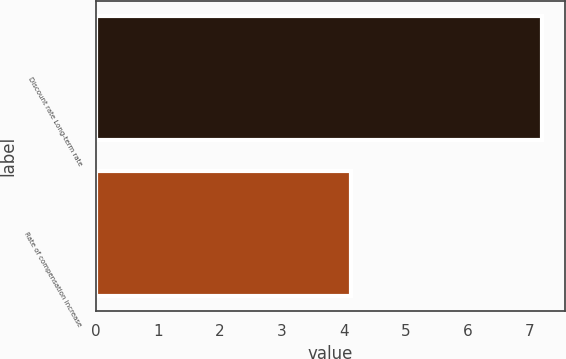<chart> <loc_0><loc_0><loc_500><loc_500><bar_chart><fcel>Discount rate Long-term rate<fcel>Rate of compensation increase<nl><fcel>7.2<fcel>4.11<nl></chart> 